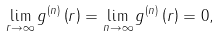<formula> <loc_0><loc_0><loc_500><loc_500>\lim _ { r \rightarrow \infty } g ^ { \left ( n \right ) } \left ( r \right ) = \lim _ { n \rightarrow \infty } g ^ { \left ( n \right ) } \left ( r \right ) = 0 ,</formula> 